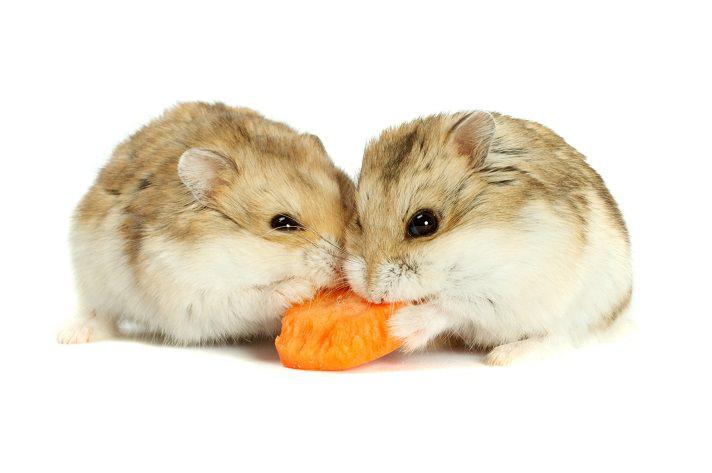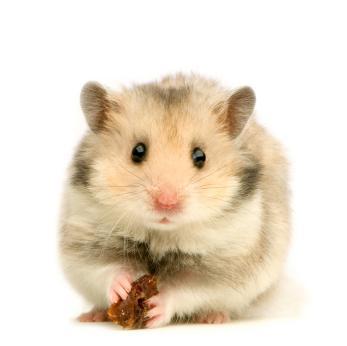The first image is the image on the left, the second image is the image on the right. For the images displayed, is the sentence "The left image contains a human hand holding at least one hamster." factually correct? Answer yes or no. No. The first image is the image on the left, the second image is the image on the right. Assess this claim about the two images: "A hand is holding multiple hamsters with mottled grayish-brown fir.". Correct or not? Answer yes or no. No. The first image is the image on the left, the second image is the image on the right. Analyze the images presented: Is the assertion "All the rodents are sitting on a white surface." valid? Answer yes or no. Yes. The first image is the image on the left, the second image is the image on the right. Assess this claim about the two images: "An image shows at least one pet rodent by a piece of bright orange food.". Correct or not? Answer yes or no. Yes. 